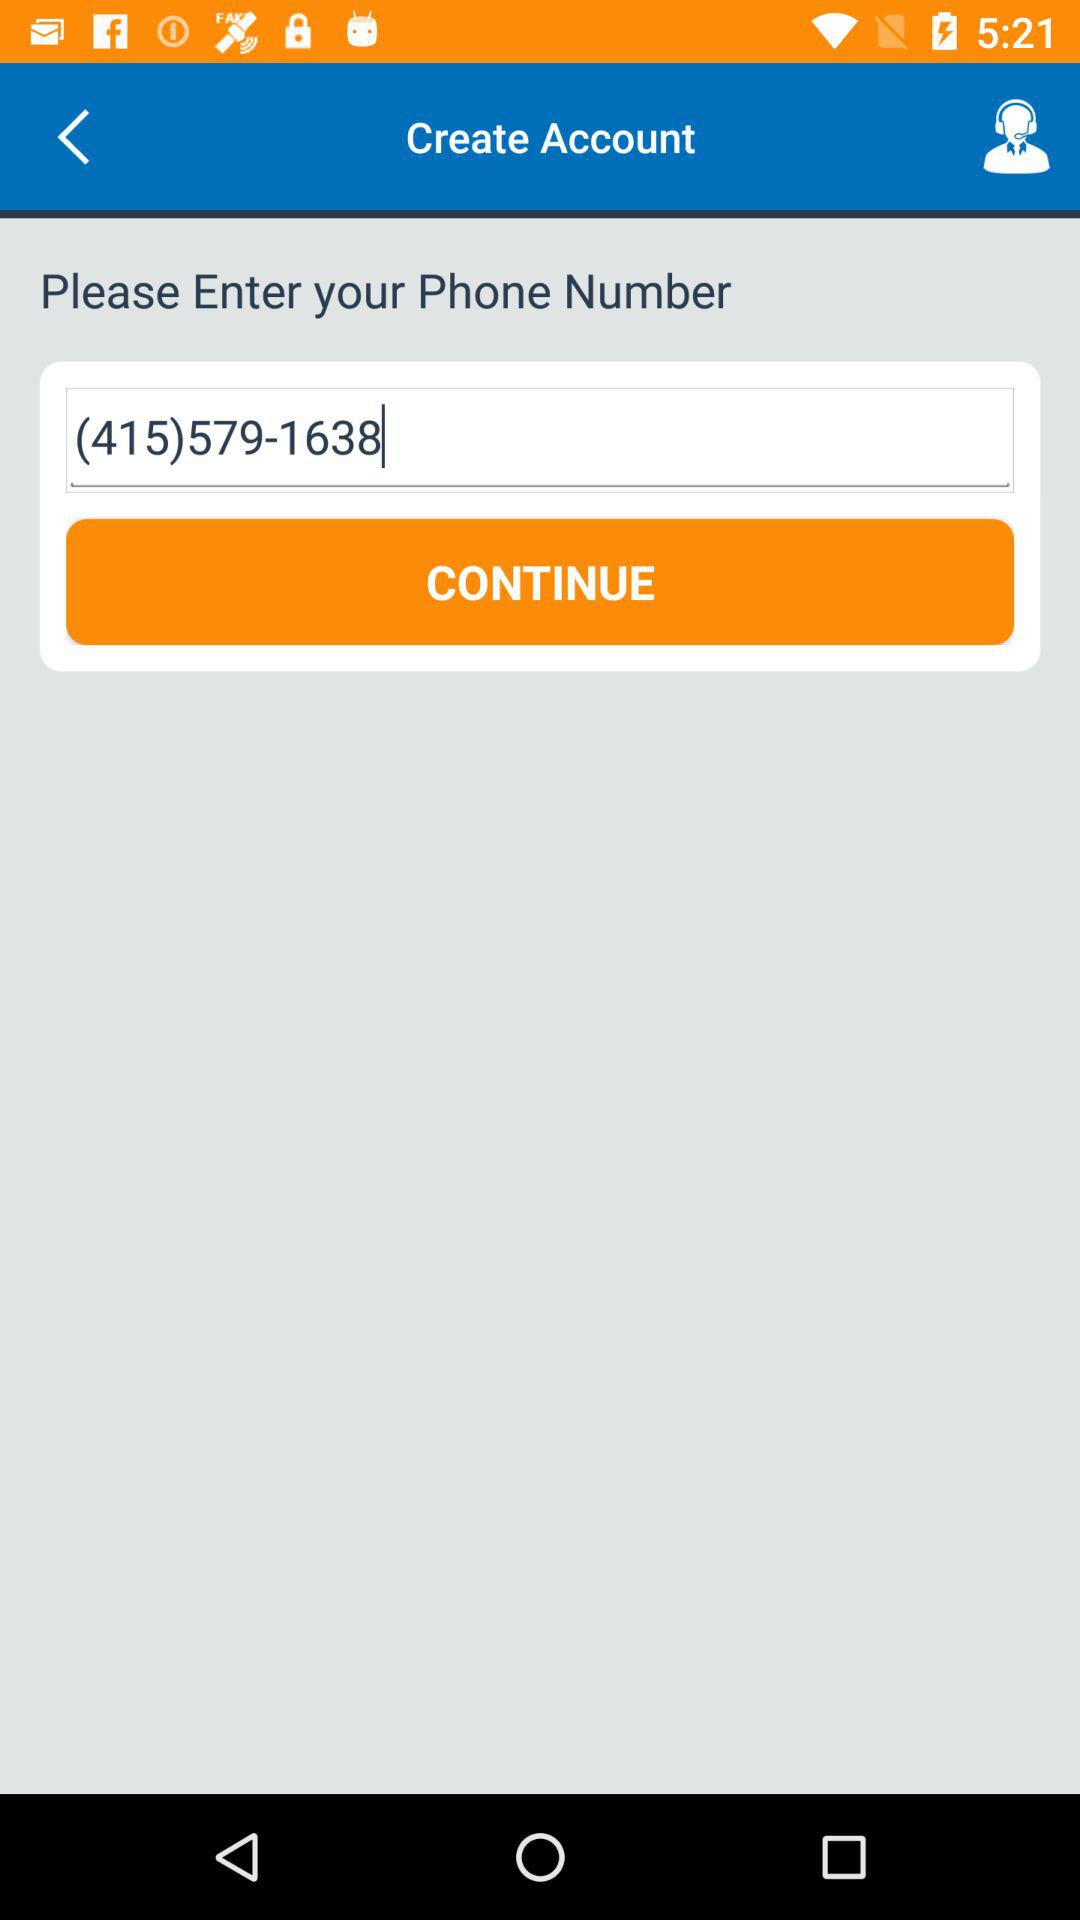Where does the user live?
When the provided information is insufficient, respond with <no answer>. <no answer> 